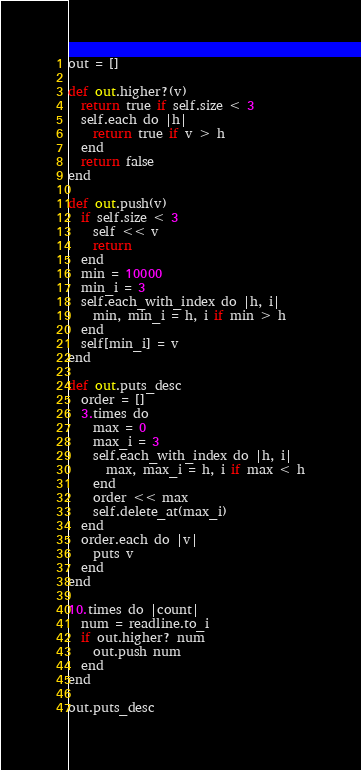Convert code to text. <code><loc_0><loc_0><loc_500><loc_500><_Python_>out = []

def out.higher?(v)
  return true if self.size < 3
  self.each do |h|
    return true if v > h
  end
  return false
end

def out.push(v)
  if self.size < 3
    self << v
    return
  end
  min = 10000
  min_i = 3
  self.each_with_index do |h, i|
    min, min_i = h, i if min > h
  end
  self[min_i] = v
end

def out.puts_desc
  order = []
  3.times do
    max = 0
    max_i = 3
    self.each_with_index do |h, i|
      max, max_i = h, i if max < h
    end
    order << max
    self.delete_at(max_i)
  end
  order.each do |v|
    puts v
  end
end

10.times do |count|
  num = readline.to_i
  if out.higher? num
    out.push num
  end
end

out.puts_desc</code> 